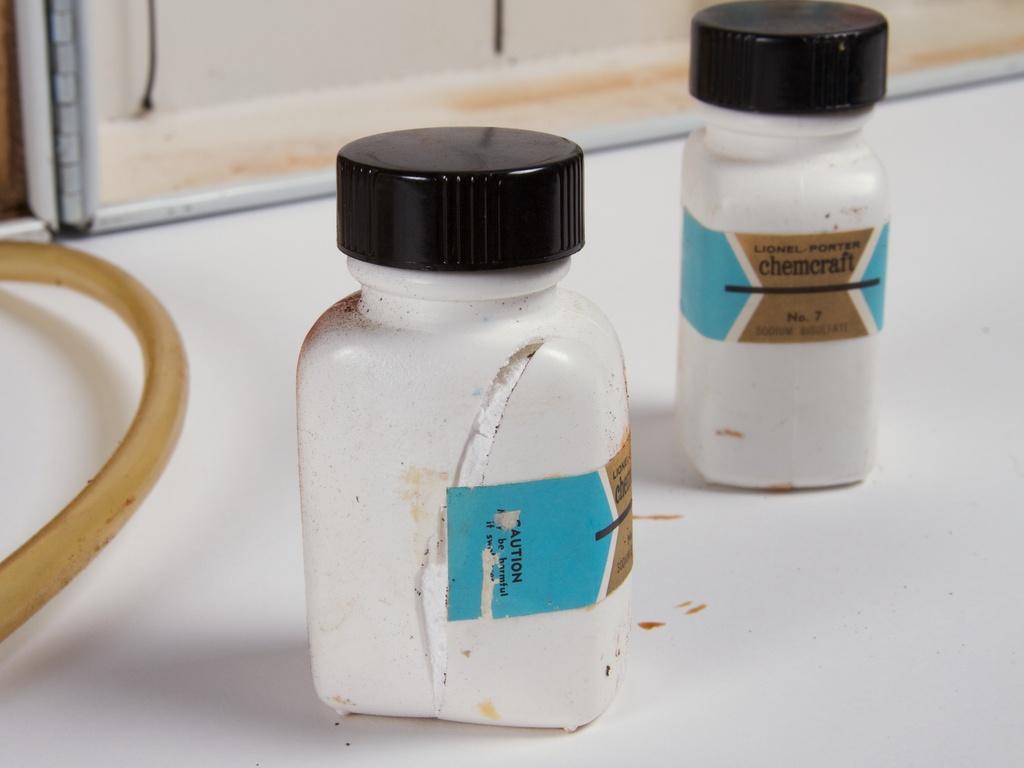What is the company listed on the bottle in the background?
Your response must be concise. Chemcraft. Is the "caution" sticker scratched a bit on the left bottle?
Your answer should be very brief. Yes. 